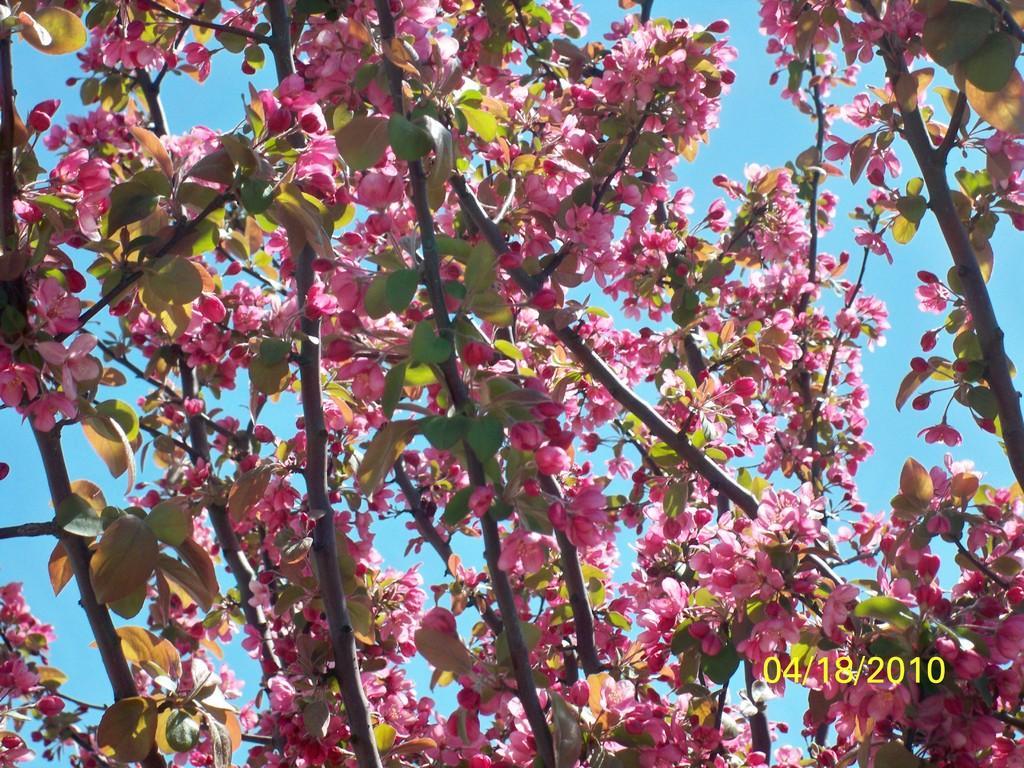How would you summarize this image in a sentence or two? In the image we can see some trees and flowers. Behind the trees we can see the sky. 